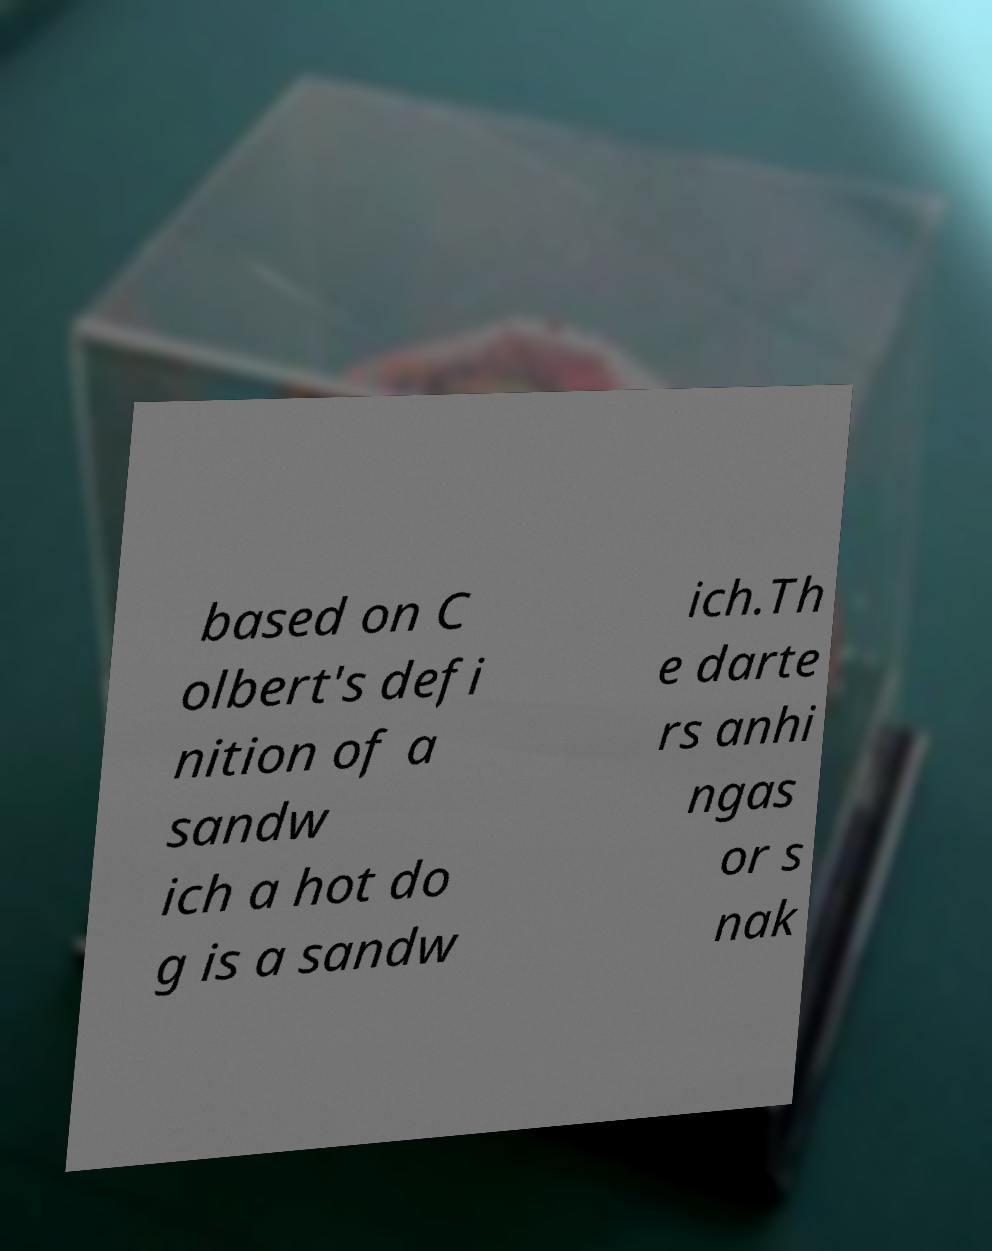Can you accurately transcribe the text from the provided image for me? based on C olbert's defi nition of a sandw ich a hot do g is a sandw ich.Th e darte rs anhi ngas or s nak 